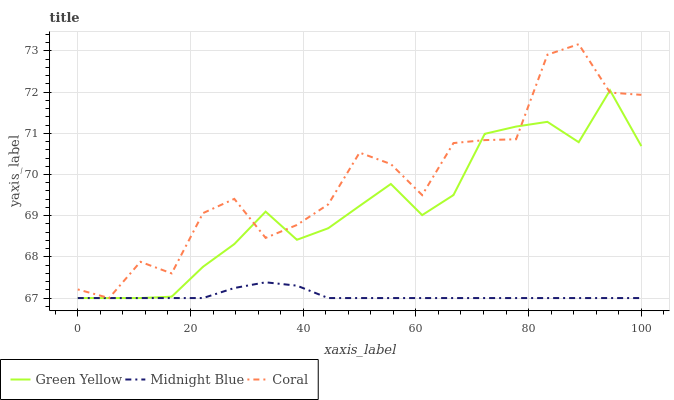Does Midnight Blue have the minimum area under the curve?
Answer yes or no. Yes. Does Coral have the maximum area under the curve?
Answer yes or no. Yes. Does Green Yellow have the minimum area under the curve?
Answer yes or no. No. Does Green Yellow have the maximum area under the curve?
Answer yes or no. No. Is Midnight Blue the smoothest?
Answer yes or no. Yes. Is Coral the roughest?
Answer yes or no. Yes. Is Green Yellow the smoothest?
Answer yes or no. No. Is Green Yellow the roughest?
Answer yes or no. No. Does Coral have the lowest value?
Answer yes or no. Yes. Does Coral have the highest value?
Answer yes or no. Yes. Does Green Yellow have the highest value?
Answer yes or no. No. Does Midnight Blue intersect Coral?
Answer yes or no. Yes. Is Midnight Blue less than Coral?
Answer yes or no. No. Is Midnight Blue greater than Coral?
Answer yes or no. No. 